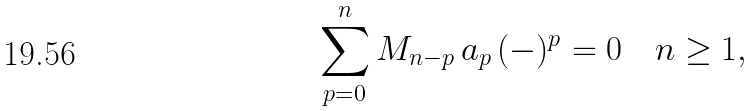<formula> <loc_0><loc_0><loc_500><loc_500>\sum _ { p = 0 } ^ { n } M _ { n - p } \, a _ { p } \, ( - ) ^ { p } = 0 \quad n \geq 1 ,</formula> 